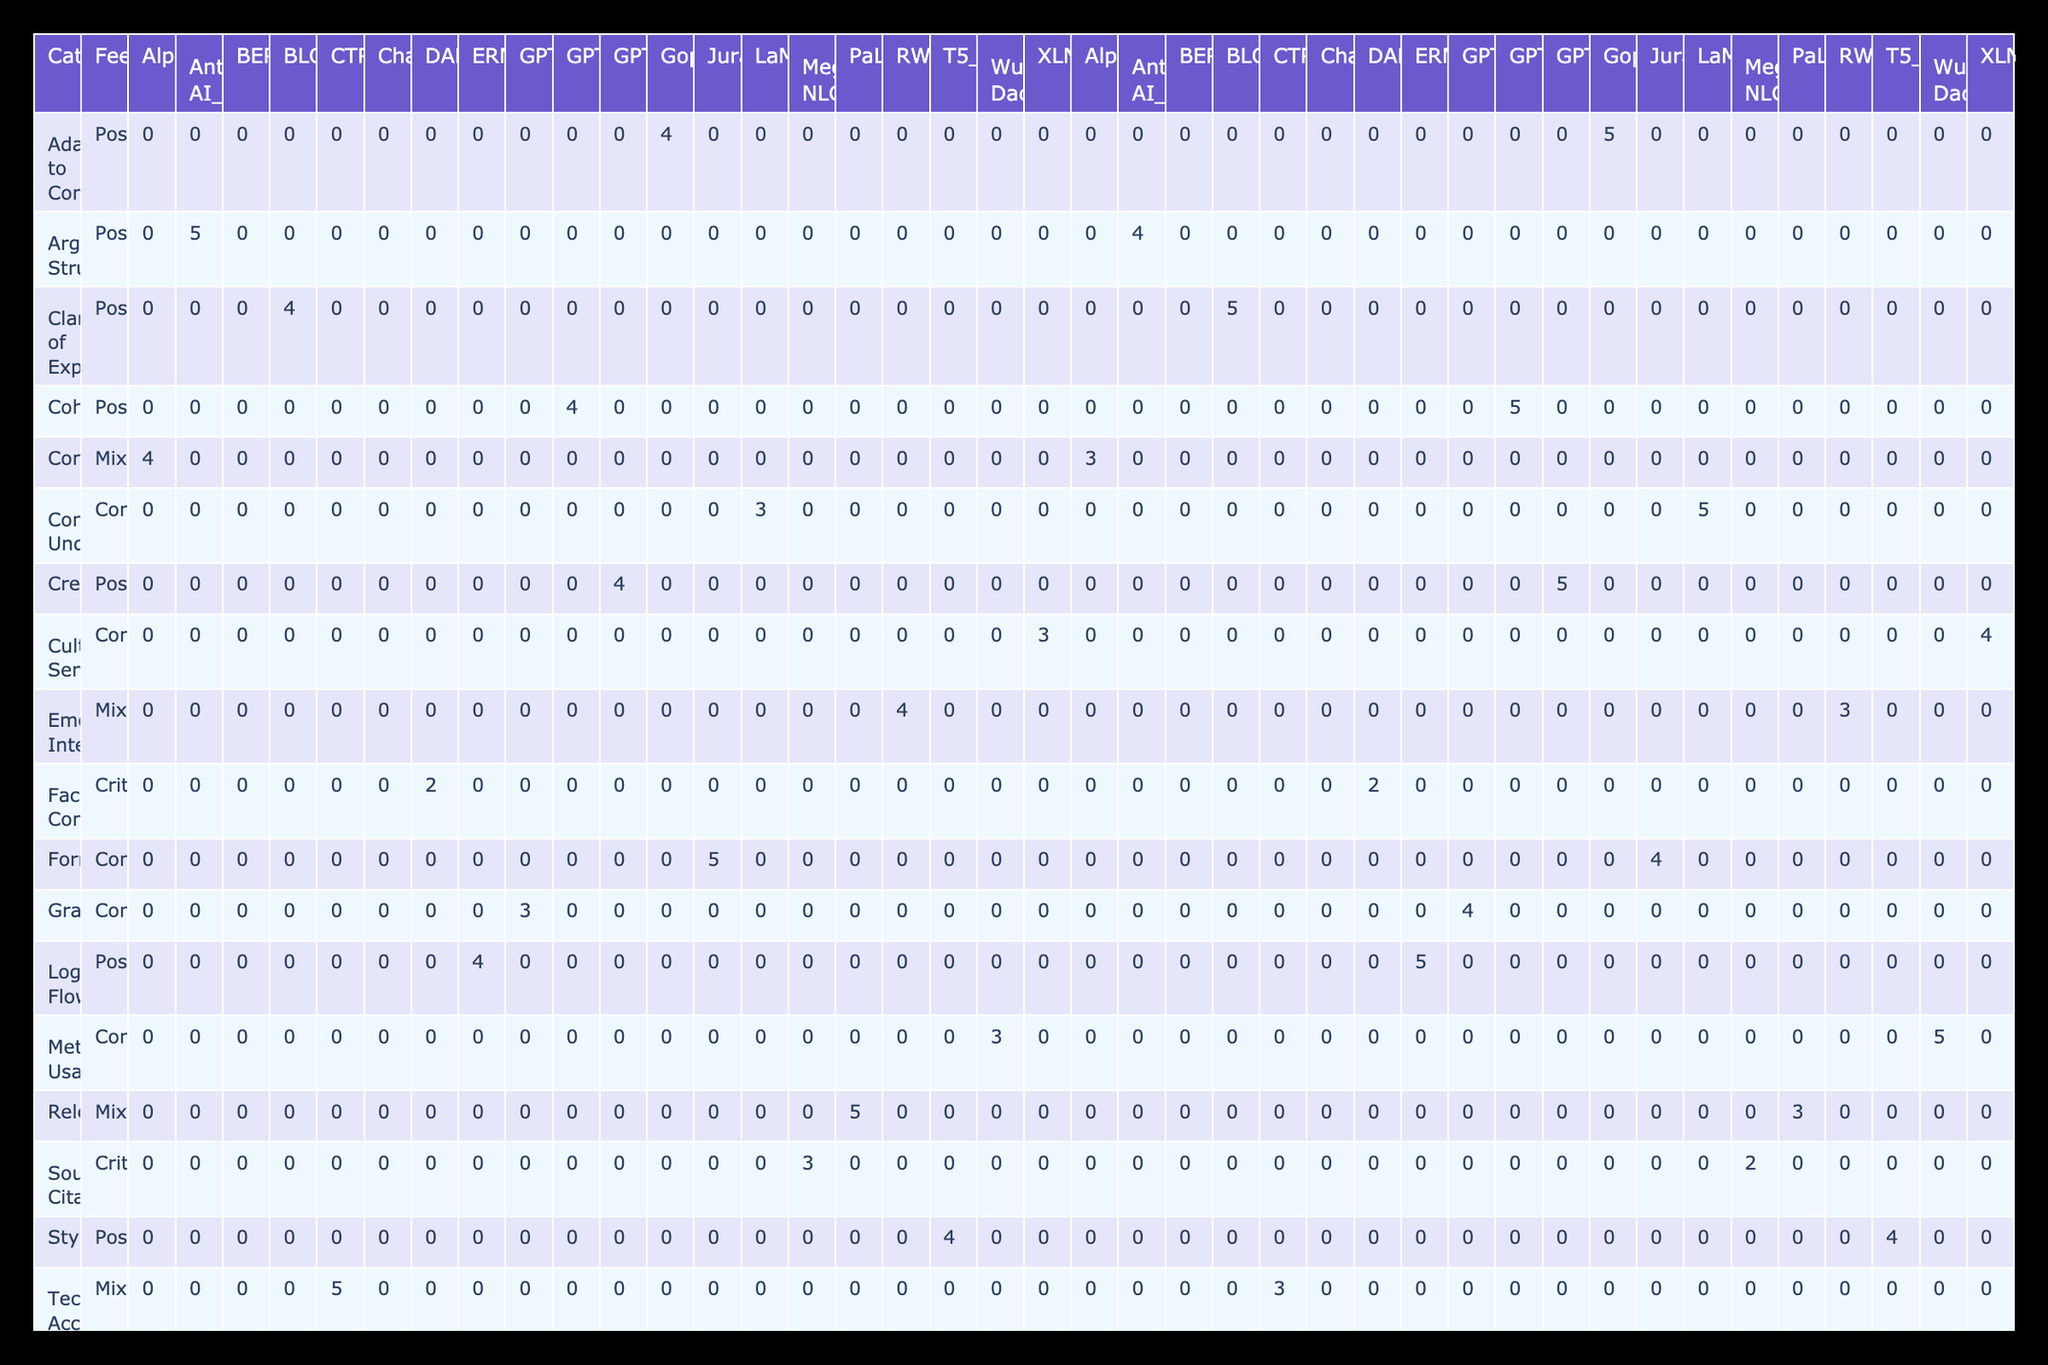What is the maximum accuracy score in the table? By examining the 'Accuracy' column across different categories and models, the highest score observed is 5, found in the 'Vocabulary', 'Relevance', and 'Technical Accuracy' categories.
Answer: 5 What feedback type is associated with the highest clarity score? The highest clarity score of 5 corresponds to multiple feedback types: 'Coherence', 'Clarity of Explanations', 'Creativity', 'Logical Flow', and 'Adaptability to Context', all associated with 'Positive' feedback.
Answer: Positive Which model received a critical feedback regarding Source Citation? The model that received critical feedback for 'Source Citation' is 'Megatron-Turing NLG', which scored 2 for both clarity and accuracy.
Answer: Megatron-Turing NLG What is the average clarity score for models with mixed feedback types? The scores for mixed feedback types (Vocabulary, Relevance, Technical Accuracy, and Emotional Intelligence) are 3, 3, 3, and 3; summing these gives 12, and dividing by 4 (the number of entries) yields an average clarity score of 3.
Answer: 3 Did any model receive a clarity score of 2 or less? The only model with a clarity score of 2 is 'DALL-E', as seen in the 'Factual Content' category.
Answer: Yes Which feedback types scored the highest average accuracy? To find this, we identify feedback types with scores of 5: 'Vocabulary', 'Relevance', and 'Technical Accuracy'. Adding the respective accuracy scores (5 + 5 + 5) = 15 for 3 categories, we conclude the average is 15/3 = 5.
Answer: 5 How many different models were evaluated in the 'Positive' feedback category? The models providing positive feedback are GPT-4, T5, BLOOM, GPT-J, ERNIE, and Gopher—totaling to 6 distinct models.
Answer: 6 What is the clarity score of the feedback type 'Constructive' for the model 'LaMDA'? The clarity score of the 'Constructive' feedback type for 'LaMDA' is documented as 5 in the 'Context Understanding' category.
Answer: 5 Which category has the lowest combined score of clarity and accuracy? The 'Factual Content' category, associated with 'DALL-E', shows the lowest combined score (2 for clarity and 2 for accuracy), totaling to 4.
Answer: Factual Content 